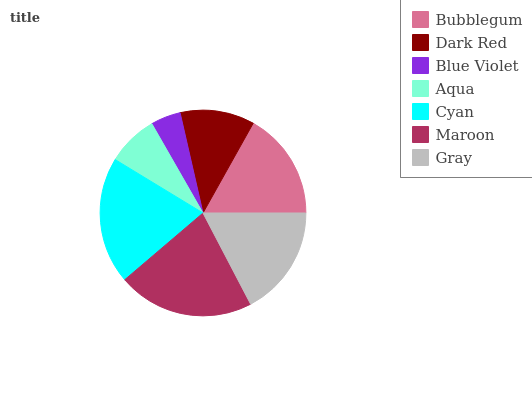Is Blue Violet the minimum?
Answer yes or no. Yes. Is Maroon the maximum?
Answer yes or no. Yes. Is Dark Red the minimum?
Answer yes or no. No. Is Dark Red the maximum?
Answer yes or no. No. Is Bubblegum greater than Dark Red?
Answer yes or no. Yes. Is Dark Red less than Bubblegum?
Answer yes or no. Yes. Is Dark Red greater than Bubblegum?
Answer yes or no. No. Is Bubblegum less than Dark Red?
Answer yes or no. No. Is Bubblegum the high median?
Answer yes or no. Yes. Is Bubblegum the low median?
Answer yes or no. Yes. Is Gray the high median?
Answer yes or no. No. Is Maroon the low median?
Answer yes or no. No. 